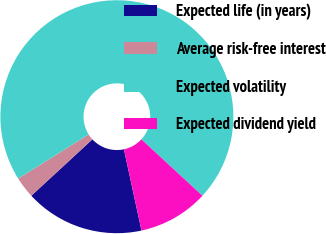<chart> <loc_0><loc_0><loc_500><loc_500><pie_chart><fcel>Expected life (in years)<fcel>Average risk-free interest<fcel>Expected volatility<fcel>Expected dividend yield<nl><fcel>16.52%<fcel>2.96%<fcel>70.78%<fcel>9.74%<nl></chart> 